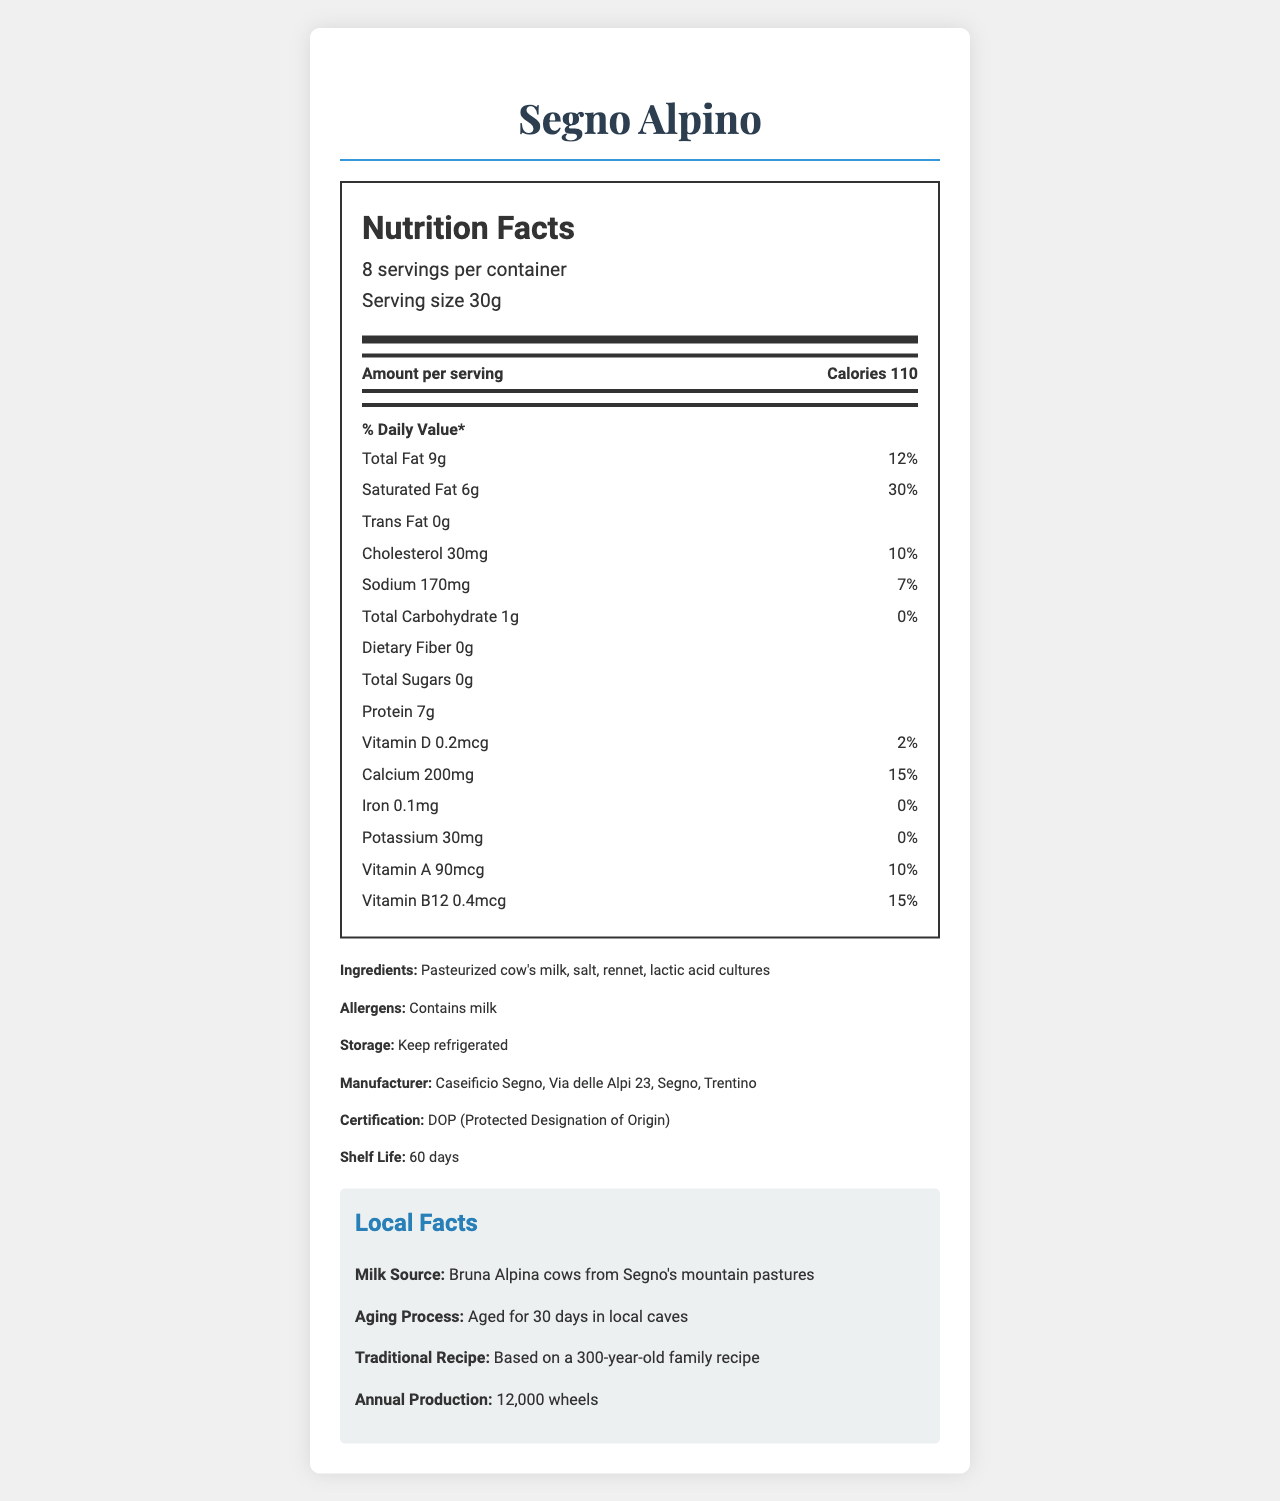How many calories are in each serving of Segno Alpino cheese? Each serving of Segno Alpino cheese contains 110 calories, as indicated under the "Amount per serving" section of the Nutrition Facts label.
Answer: 110 What is the serving size of Segno Alpino cheese? The serving size is specified as 30 grams on the Nutrition Facts label.
Answer: 30g What percentage of the daily value for saturated fat does one serving of Segno Alpino cheese provide? The Nutrition Facts label shows that one serving provides 30% of the daily value for saturated fat.
Answer: 30% Which nutrient is present in the smallest amount in Segno Alpino cheese? The label indicates that dietary fiber is 0g, making it the smallest amount among the listed nutrients.
Answer: Dietary Fiber What is the recommended storage condition for Segno Alpino cheese? The recommended storage condition is to keep the cheese refrigerated, as indicated in the "Storage" section.
Answer: Keep refrigerated Where is the manufacturer of Segno Alpino cheese located? The manufacturer's address is specified as Caseificio Segno, Via delle Alpi 23, Segno, Trentino.
Answer: Via delle Alpi 23, Segno, Trentino What percentage of the daily value for calcium does one serving of Segno Alpino cheese provide? A. 5% B. 10% C. 15% D. 20% One serving of Segno Alpino cheese provides 15% of the daily value for calcium, as indicated on the Nutrition Facts label.
Answer: C. 15% How many servings are there in a container of Segno Alpino cheese? 1. 6 servings 2. 7 servings 3. 8 servings The document states that there are 8 servings per container.
Answer: 3. 8 servings Is there any trans fat in Segno Alpino cheese? The label indicates that there is 0g of trans fat in one serving.
Answer: No Give an overview of the Nutrition Facts label and local facts of Segno Alpino cheese. The Nutrition Facts label states that the cheese provides 110 calories per 30g serving, with notable amounts of fat, protein, and calcium. The fat content includes 9g of total fat, with 6g being saturated fat. The local facts reveal the traditional, locally-sourced methods of production, emphasizing the use of milk from Bruna Alpina cows and aging in local caves.
Answer: The Nutrition Facts label provides detailed information about the caloric content and various nutrients in each 30g serving of Segno Alpino cheese, including total fat, saturated fat, cholesterol, sodium, carbohydrates, protein, and several vitamins and minerals. Additionally, it includes information on ingredients, allergens, storage conditions, manufacturer, certification, and shelf life. Local facts highlight the source of the milk, the aging process, the traditional recipe used, and the annual production. How many wheels of Segno Alpino cheese are produced annually? The document states that the annual production is 12,000 wheels.
Answer: 12,000 Which ingredient is not listed on the Segno Alpino cheese label? The ingredients listed on the label include pasteurized cow's milk, salt, rennet, and lactic acid cultures. Lactose is not specifically mentioned.
Answer: Lactose Does Segno Alpino cheese contain Vitamin D? The Nutrition Facts label shows that the cheese contains 0.2mcg of Vitamin D, providing 2% of the daily value.
Answer: Yes What is the cholesterol content per serving? Each serving contains 30mg of cholesterol as indicated on the Nutrition Facts label.
Answer: 30mg Is it stated which mix of cultures is used in Segno Alpino cheese? The document only mentions "lactic acid cultures" but does not specify the mix or types of cultures used.
Answer: Not enough information 